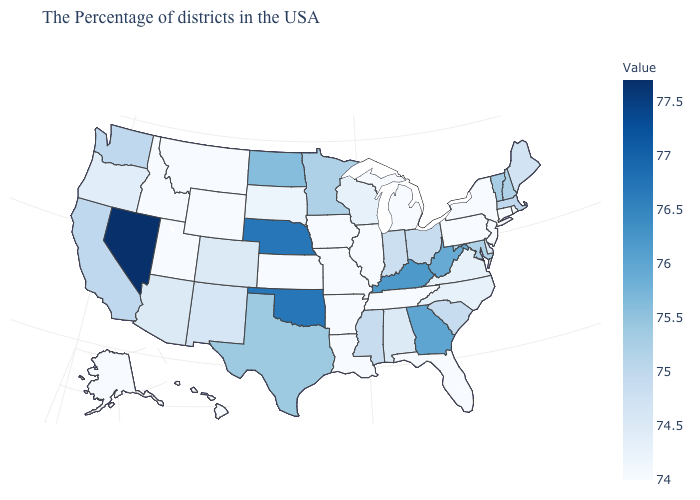Which states hav the highest value in the West?
Answer briefly. Nevada. Among the states that border South Carolina , does Georgia have the lowest value?
Quick response, please. No. Which states have the lowest value in the West?
Keep it brief. Wyoming, Utah, Montana, Idaho, Alaska, Hawaii. Among the states that border New York , does New Jersey have the highest value?
Give a very brief answer. No. Does Montana have the lowest value in the West?
Keep it brief. Yes. Among the states that border New Hampshire , which have the highest value?
Answer briefly. Vermont. Does Arkansas have the lowest value in the South?
Keep it brief. Yes. 